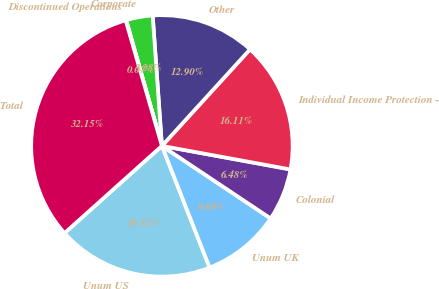Convert chart to OTSL. <chart><loc_0><loc_0><loc_500><loc_500><pie_chart><fcel>Unum US<fcel>Unum UK<fcel>Colonial<fcel>Individual Income Protection -<fcel>Other<fcel>Corporate<fcel>Discontinued Operations<fcel>Total<nl><fcel>19.32%<fcel>9.69%<fcel>6.48%<fcel>16.11%<fcel>12.9%<fcel>3.28%<fcel>0.07%<fcel>32.15%<nl></chart> 